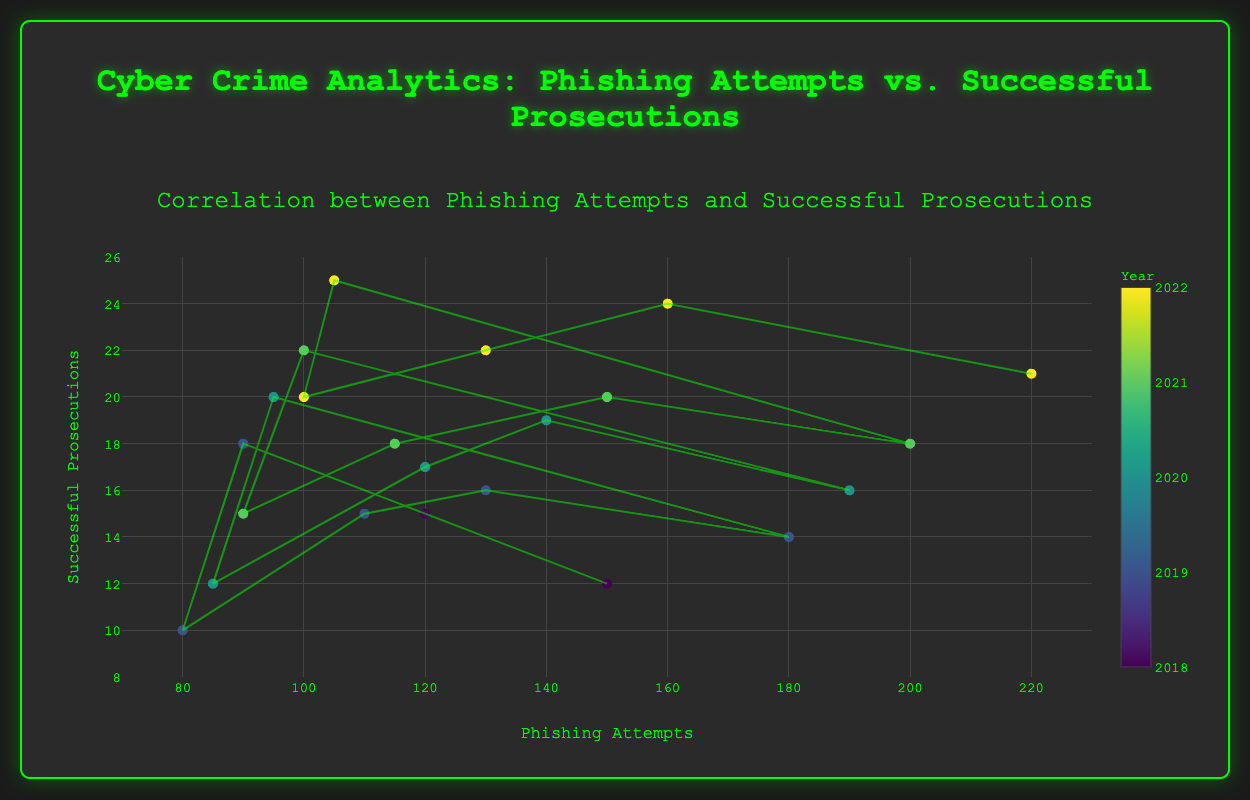How many data points are shown in the scatter plot? By counting each individual marker that represents a data point on the scatter plot, we can determine the total number of data points. There are 22 data points in the figure.
Answer: 22 What is the range of phishing attempts displayed on the x-axis? The x-axis shows the number of phishing attempts. From the figure, the x-axis ranges from 70 to 230.
Answer: 70 to 230 What is the general trend observed between phishing attempts and successful prosecutions? Observe the trend line drawn through the scatter points. The trend line slopes upward, indicating a positive relationship between phishing attempts and successful prosecutions: as phishing attempts increase, successful prosecutions tend to increase as well.
Answer: Positive relationship Which year had the highest number of phishing attempts during the Christmas season? By looking at the data points colored by year and identifying the Christmas season in the hover text, we can see that the year 2022 had the highest number of phishing attempts, with 220 attempts.
Answer: 2022 During which holiday season in 2020 were phishing attempts the lowest, and what was the corresponding number of successful prosecutions? Look at the markers for different seasons in the year 2020. The 4th of July had the lowest phishing attempts with 85, and the corresponding successful prosecutions were 12.
Answer: 4th of July, 85 attempts, 12 prosecutions What is the maximum number of successful prosecutions observed, and during which season did it occur? Check the y-axis to find the highest value and hover over the highest data points. The maximum number of successful prosecutions is 25, which occurred during the February-Valentine's Day season in 2022.
Answer: 25, February-Valentine's Day Compare the number of phishing attempts during the Halloween season between 2019 and 2020. Which year had more attempts? Look at the hover text for October-Halloween for the years 2019 and 2020. In 2019, there were 110 attempts, and in 2020, there were 120 attempts. Therefore, 2020 had more attempts.
Answer: 2020 What is the average number of successful prosecutions for the Thanksgiving seasons across all years? Identify the successful prosecutions for the Thanksgiving seasons: 15 (2018), 16 (2019), 19 (2020), 20 (2021), 24 (2022). Calculate the average: (15 + 16 + 19 + 20 + 24) / 5 = 18.8.
Answer: 18.8 How does the number of successful prosecutions compare between the 4th of July seasons in 2019 and 2022? Refer to the data points for the 4th of July season in 2019 and 2022. In 2019, there were 10 successful prosecutions, and in 2022, there were 20 successful prosecutions. Therefore, 2022 had more prosecutions.
Answer: 2022 had more successful prosecutions During the Christmas season in 2021, how many successful prosecutions were there, and how does it compare to the number of phishing attempts? Locate the data point for the Christmas season in 2021. The hover text shows that there were 18 successful prosecutions and 200 phishing attempts. Comparatively, there were significantly more phishing attempts than successful prosecutions.
Answer: 18 prosecutions, significantly more attempts 